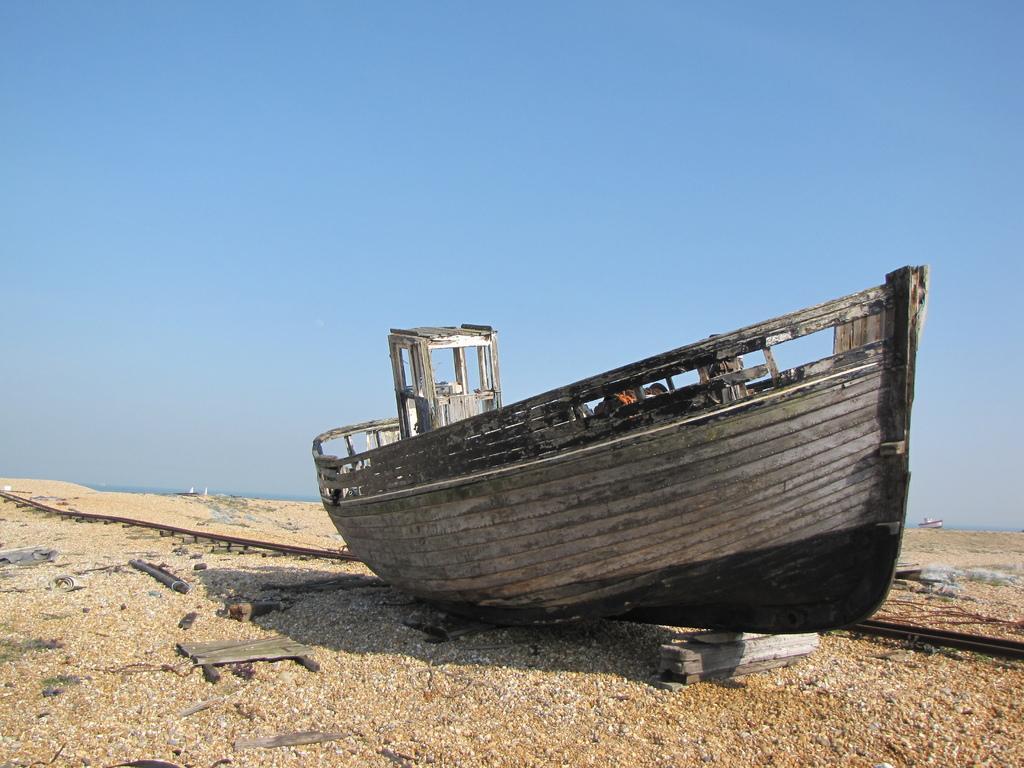Can you describe this image briefly? In this image we can see one wooden boat on the ground, some objects in the boat, one small white boat, some and, some objects on the ground and there is the sky in the background. 